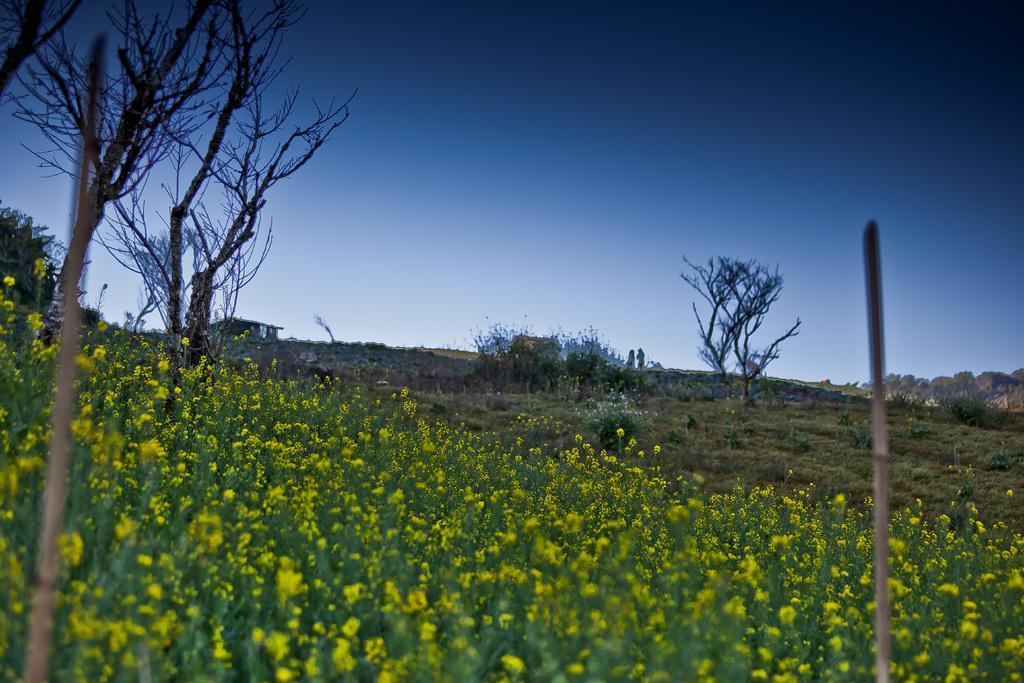Could you give a brief overview of what you see in this image? In this image on the left side I can see some yellow flowers. I can see the grass. In the background, I can see the trees and the sky. 